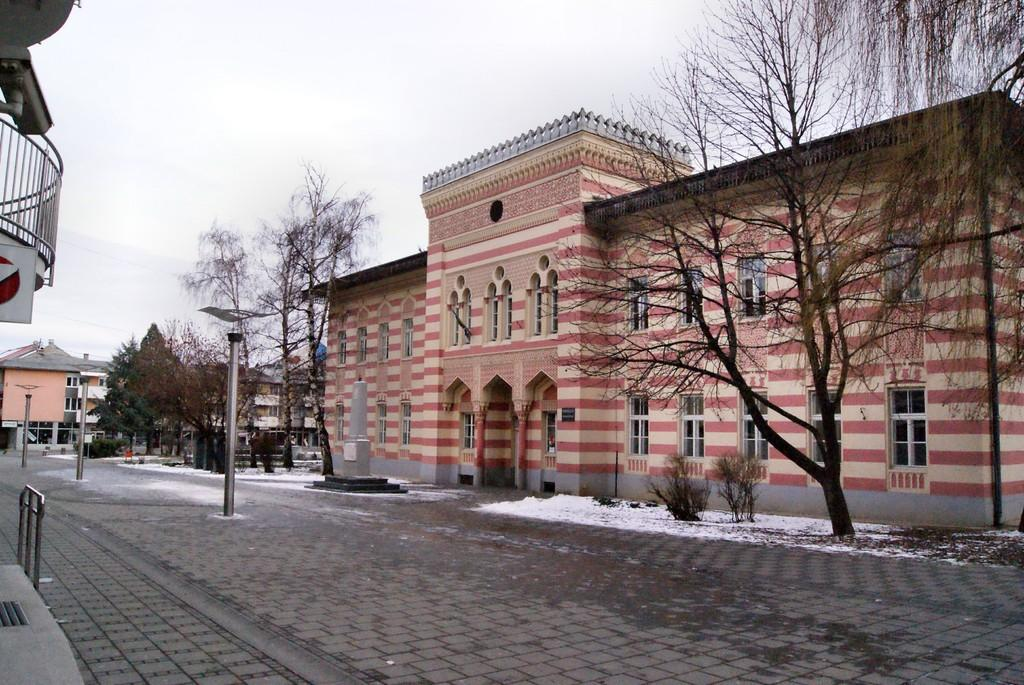What type of structures can be seen in the image? There are buildings in the image. What type of vegetation is present in the image? There are trees in the image. What are the tall, thin objects in the image? There are poles in the image. What is covering the road in the image? There is snow on the road in the image. How does the image show respect for the elderly? The image does not show respect for the elderly, as it only contains buildings, trees, poles, and snow on the road. What type of rest can be seen in the image? There is no rest visible in the image, as it only contains buildings, trees, poles, and snow on the road. 